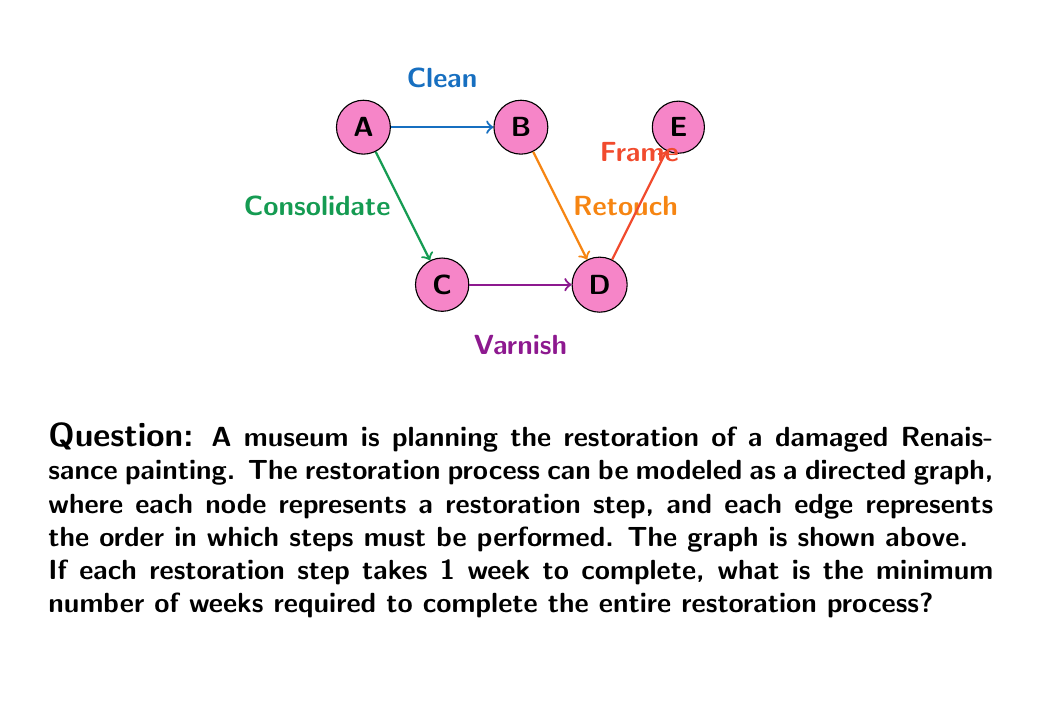Show me your answer to this math problem. To solve this problem, we need to find the longest path in the directed graph, which is also known as the critical path. This path represents the sequence of steps that will take the longest time to complete, determining the minimum duration of the entire project.

Let's analyze the graph step by step:

1) First, we identify all possible paths from start (node A) to finish (node E):
   Path 1: A → B → D → E
   Path 2: A → C → D → E

2) Now, we calculate the length of each path:
   Path 1: A → B → D → E = 1 + 1 + 1 = 3 weeks
   Path 2: A → C → D → E = 1 + 1 + 1 = 3 weeks

3) The critical path is the longest path, which in this case is 3 weeks for both paths.

4) Therefore, the minimum number of weeks required to complete the entire restoration process is 3 weeks.

This approach using graph theory allows us to model complex restoration processes and determine the minimum time required, which is crucial for project planning in art conservation.
Answer: 3 weeks 